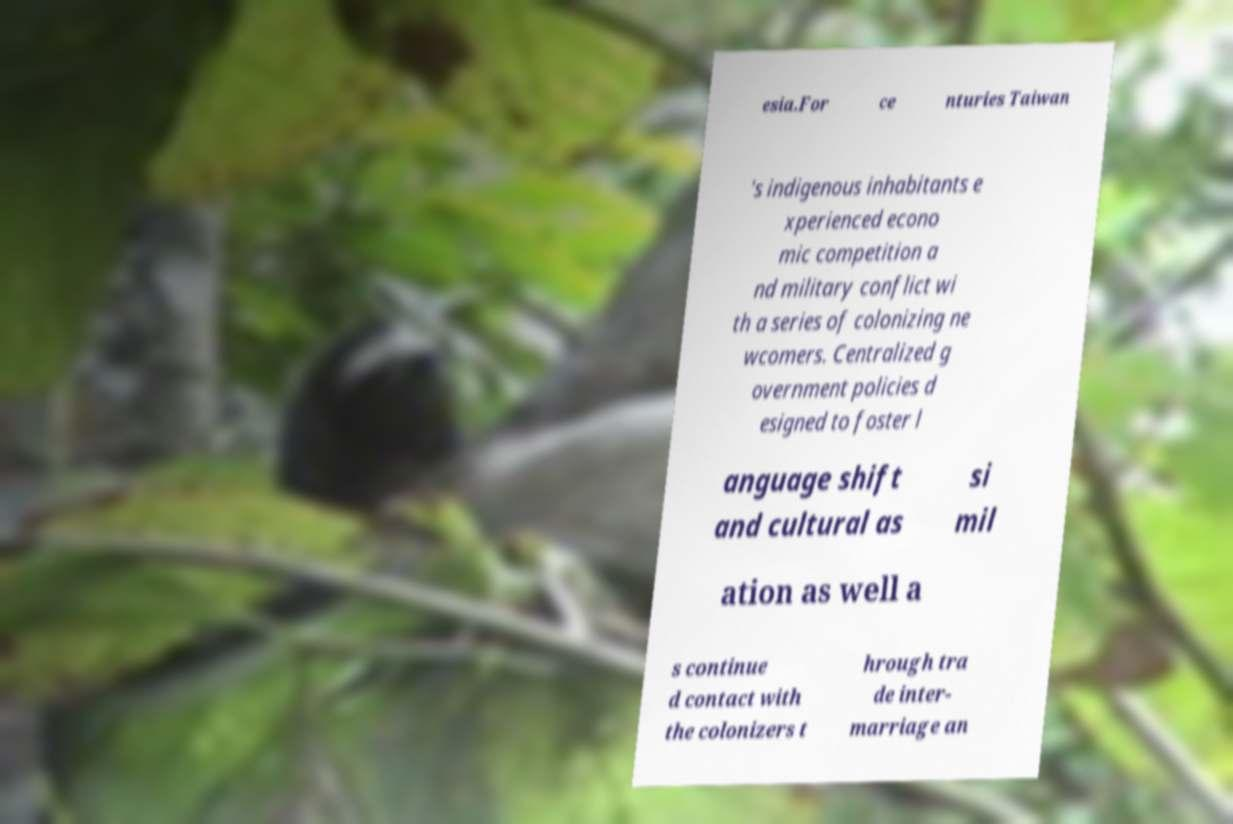There's text embedded in this image that I need extracted. Can you transcribe it verbatim? esia.For ce nturies Taiwan 's indigenous inhabitants e xperienced econo mic competition a nd military conflict wi th a series of colonizing ne wcomers. Centralized g overnment policies d esigned to foster l anguage shift and cultural as si mil ation as well a s continue d contact with the colonizers t hrough tra de inter- marriage an 